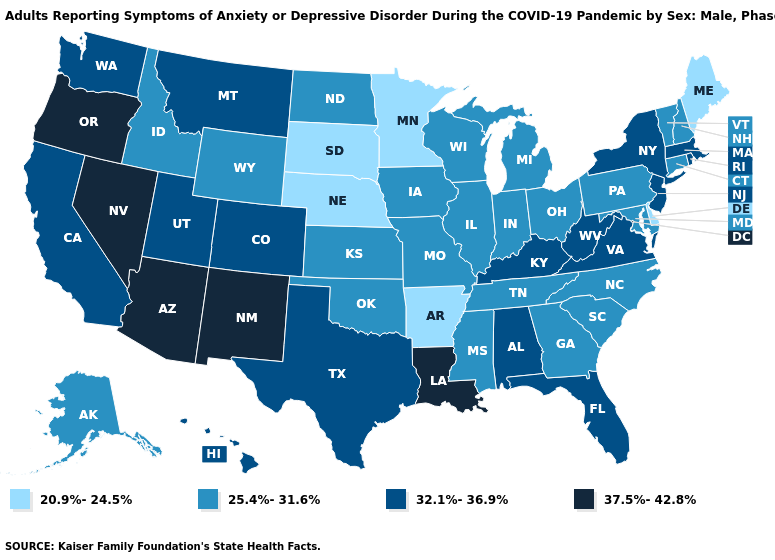Name the states that have a value in the range 25.4%-31.6%?
Keep it brief. Alaska, Connecticut, Georgia, Idaho, Illinois, Indiana, Iowa, Kansas, Maryland, Michigan, Mississippi, Missouri, New Hampshire, North Carolina, North Dakota, Ohio, Oklahoma, Pennsylvania, South Carolina, Tennessee, Vermont, Wisconsin, Wyoming. Which states hav the highest value in the West?
Concise answer only. Arizona, Nevada, New Mexico, Oregon. Does Michigan have a higher value than New York?
Quick response, please. No. Does Minnesota have the highest value in the MidWest?
Write a very short answer. No. What is the value of New York?
Concise answer only. 32.1%-36.9%. What is the lowest value in the Northeast?
Short answer required. 20.9%-24.5%. How many symbols are there in the legend?
Answer briefly. 4. What is the value of Connecticut?
Be succinct. 25.4%-31.6%. How many symbols are there in the legend?
Short answer required. 4. What is the value of Washington?
Give a very brief answer. 32.1%-36.9%. Which states hav the highest value in the Northeast?
Short answer required. Massachusetts, New Jersey, New York, Rhode Island. Does the first symbol in the legend represent the smallest category?
Quick response, please. Yes. Name the states that have a value in the range 25.4%-31.6%?
Quick response, please. Alaska, Connecticut, Georgia, Idaho, Illinois, Indiana, Iowa, Kansas, Maryland, Michigan, Mississippi, Missouri, New Hampshire, North Carolina, North Dakota, Ohio, Oklahoma, Pennsylvania, South Carolina, Tennessee, Vermont, Wisconsin, Wyoming. Does the map have missing data?
Write a very short answer. No. What is the value of Rhode Island?
Short answer required. 32.1%-36.9%. 